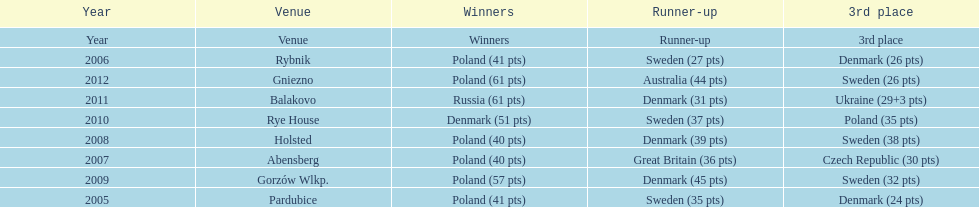What is the total number of points earned in the years 2009? 134. 